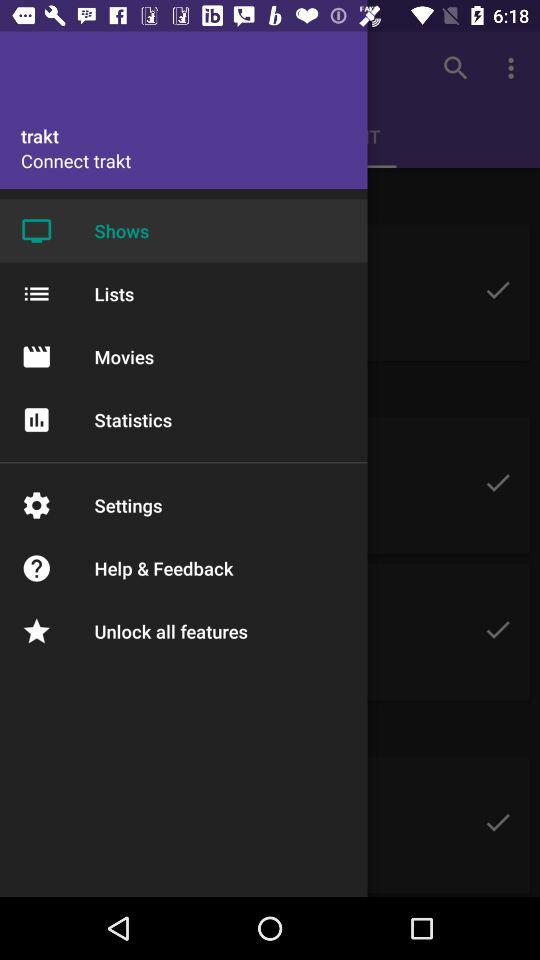What is the application name? The application name is "trakt". 